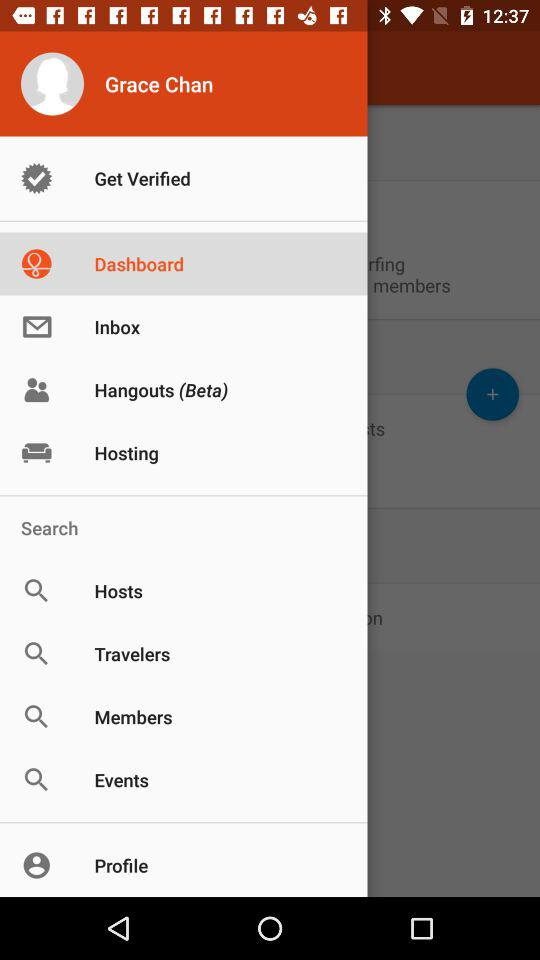What is the name of the user? The name of the user is Grace Chan. 